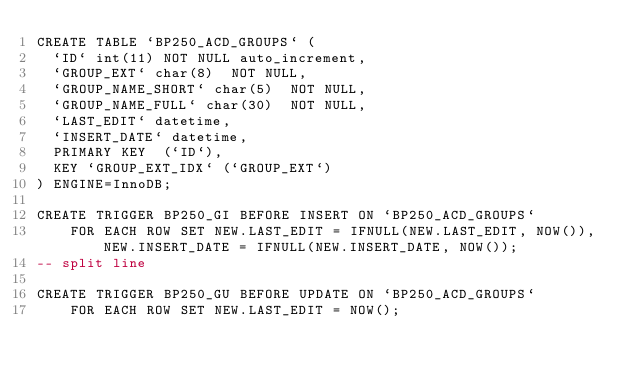Convert code to text. <code><loc_0><loc_0><loc_500><loc_500><_SQL_>CREATE TABLE `BP250_ACD_GROUPS` (
  `ID` int(11) NOT NULL auto_increment,
  `GROUP_EXT` char(8)  NOT NULL,
  `GROUP_NAME_SHORT` char(5)  NOT NULL,
  `GROUP_NAME_FULL` char(30)  NOT NULL,
  `LAST_EDIT` datetime,
  `INSERT_DATE` datetime,
  PRIMARY KEY  (`ID`),
  KEY `GROUP_EXT_IDX` (`GROUP_EXT`)
) ENGINE=InnoDB;

CREATE TRIGGER BP250_GI BEFORE INSERT ON `BP250_ACD_GROUPS`
    FOR EACH ROW SET NEW.LAST_EDIT = IFNULL(NEW.LAST_EDIT, NOW()), NEW.INSERT_DATE = IFNULL(NEW.INSERT_DATE, NOW());
-- split line

CREATE TRIGGER BP250_GU BEFORE UPDATE ON `BP250_ACD_GROUPS`
    FOR EACH ROW SET NEW.LAST_EDIT = NOW();</code> 